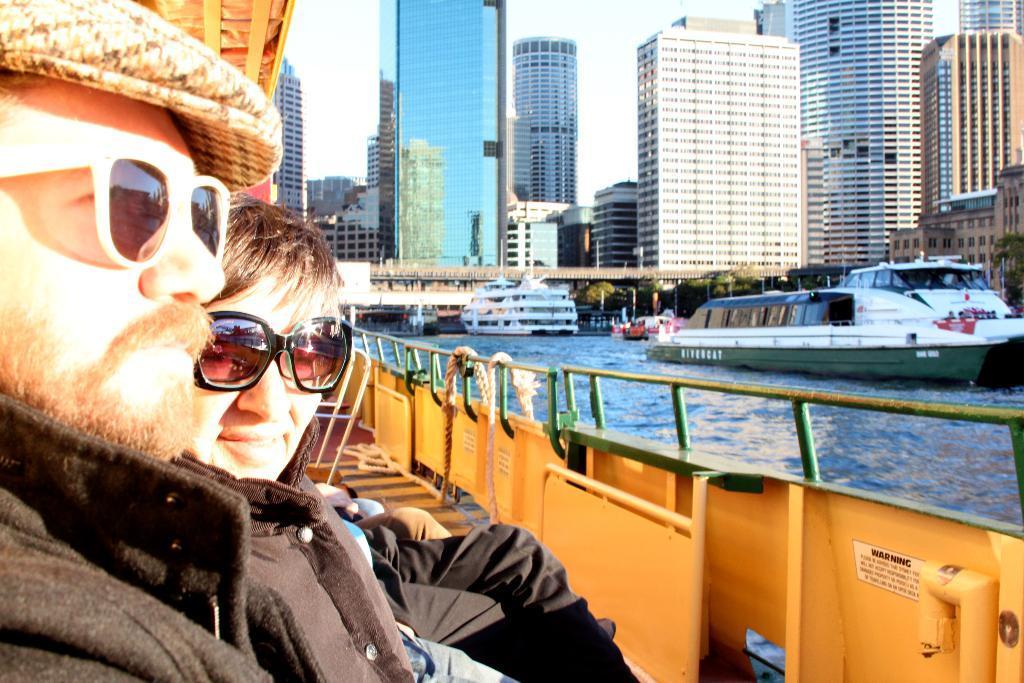Can you describe this image briefly? In this picture I can see a number of ships on the water. I can see people on the ship. I can see tower buildings. I can see the bridge. 